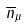<formula> <loc_0><loc_0><loc_500><loc_500>\overline { n } _ { \mu }</formula> 